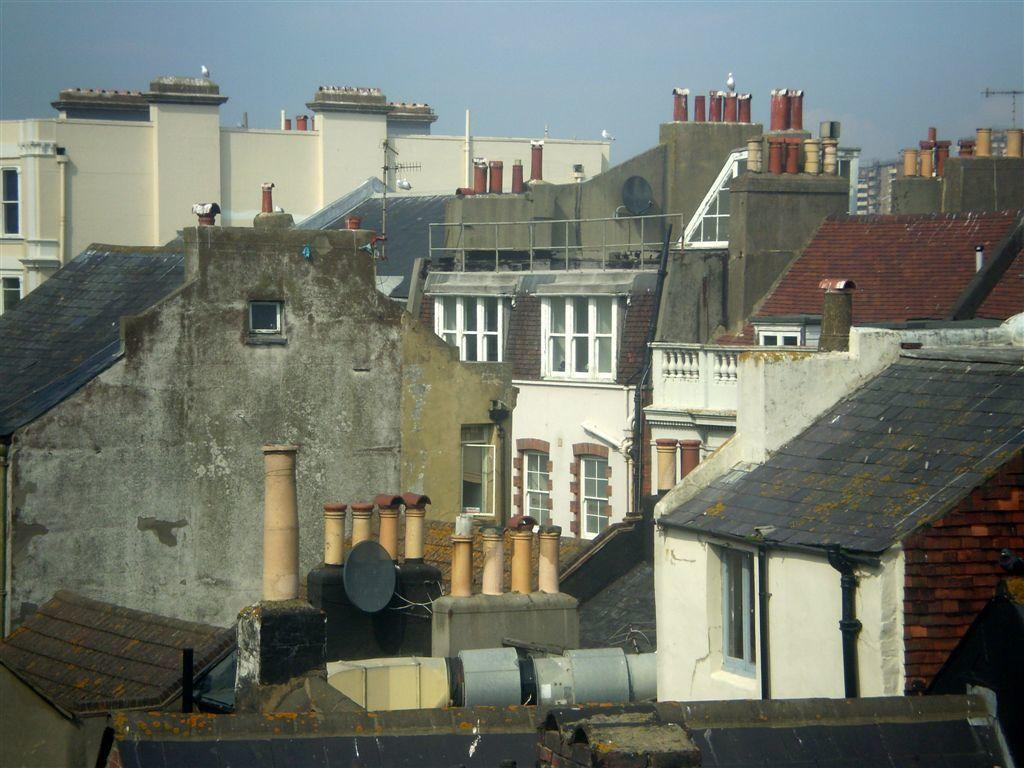What type of structures can be seen in the image? There are buildings in the image. What part of the natural environment is visible in the image? The sky is visible in the image. How many stems are visible in the image? There are no stems present in the image. What type of doll can be seen interacting with the buildings in the image? There is no doll present in the image; it only features buildings and the sky. 